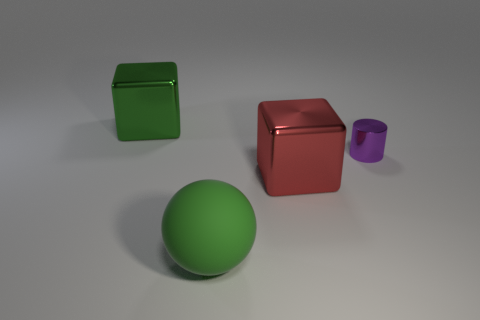What can you infer about the texture of the objects? Based on the image, all the objects have a smooth texture with a somewhat shiny surface, reflecting a bit of the light that is illuminating them. Do you think these objects are made of the same material? It's possible that all these objects are made of the same material, likely a type of plastic or metal, given their reflective qualities and uniformity in texture. 